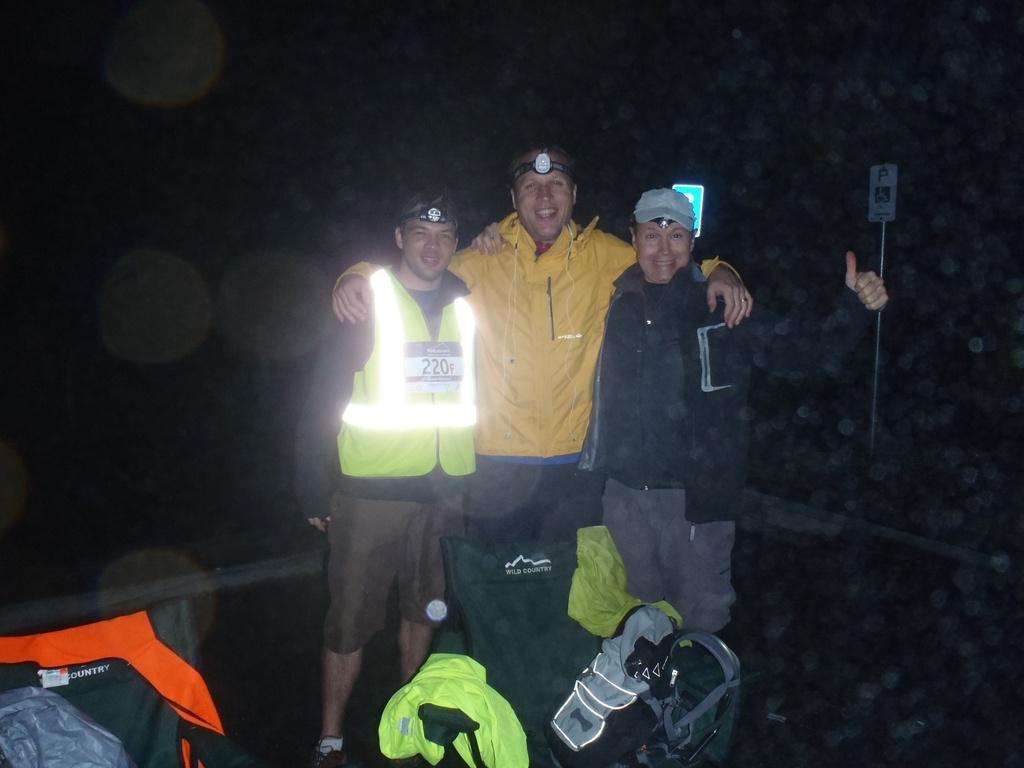How would you summarize this image in a sentence or two? In the middle of the image, there are three persons in different color dresses, smiling and standing. Beside them, there are clothes on an object. On the left side, there is a cloth. And the background is dark in color. 